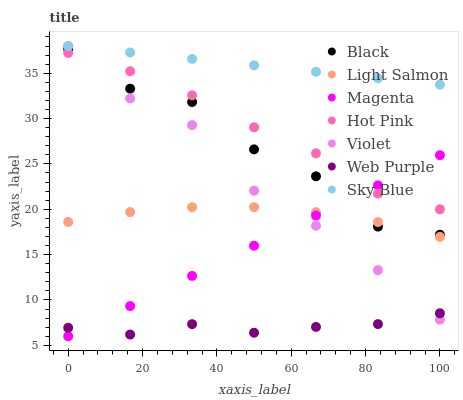Does Web Purple have the minimum area under the curve?
Answer yes or no. Yes. Does Sky Blue have the maximum area under the curve?
Answer yes or no. Yes. Does Hot Pink have the minimum area under the curve?
Answer yes or no. No. Does Hot Pink have the maximum area under the curve?
Answer yes or no. No. Is Magenta the smoothest?
Answer yes or no. Yes. Is Black the roughest?
Answer yes or no. Yes. Is Hot Pink the smoothest?
Answer yes or no. No. Is Hot Pink the roughest?
Answer yes or no. No. Does Magenta have the lowest value?
Answer yes or no. Yes. Does Hot Pink have the lowest value?
Answer yes or no. No. Does Sky Blue have the highest value?
Answer yes or no. Yes. Does Hot Pink have the highest value?
Answer yes or no. No. Is Web Purple less than Black?
Answer yes or no. Yes. Is Light Salmon greater than Web Purple?
Answer yes or no. Yes. Does Light Salmon intersect Violet?
Answer yes or no. Yes. Is Light Salmon less than Violet?
Answer yes or no. No. Is Light Salmon greater than Violet?
Answer yes or no. No. Does Web Purple intersect Black?
Answer yes or no. No. 